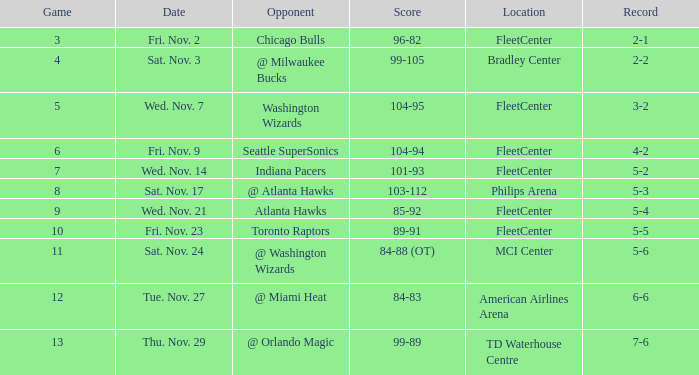Which opponent has a score of 84-88 (ot)? @ Washington Wizards. 